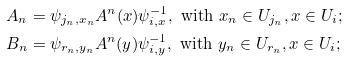Convert formula to latex. <formula><loc_0><loc_0><loc_500><loc_500>A _ { n } & = \psi _ { j _ { n } , x _ { n } } A ^ { n } ( x ) \psi _ { i , x } ^ { - 1 } , \text { with } x _ { n } \in U _ { j _ { n } } , x \in U _ { i } ; \\ B _ { n } & = \psi _ { r _ { n } , y _ { n } } A ^ { n } ( y ) \psi _ { i , y } ^ { - 1 } , \text { with } y _ { n } \in U _ { r _ { n } } , x \in U _ { i } ;</formula> 